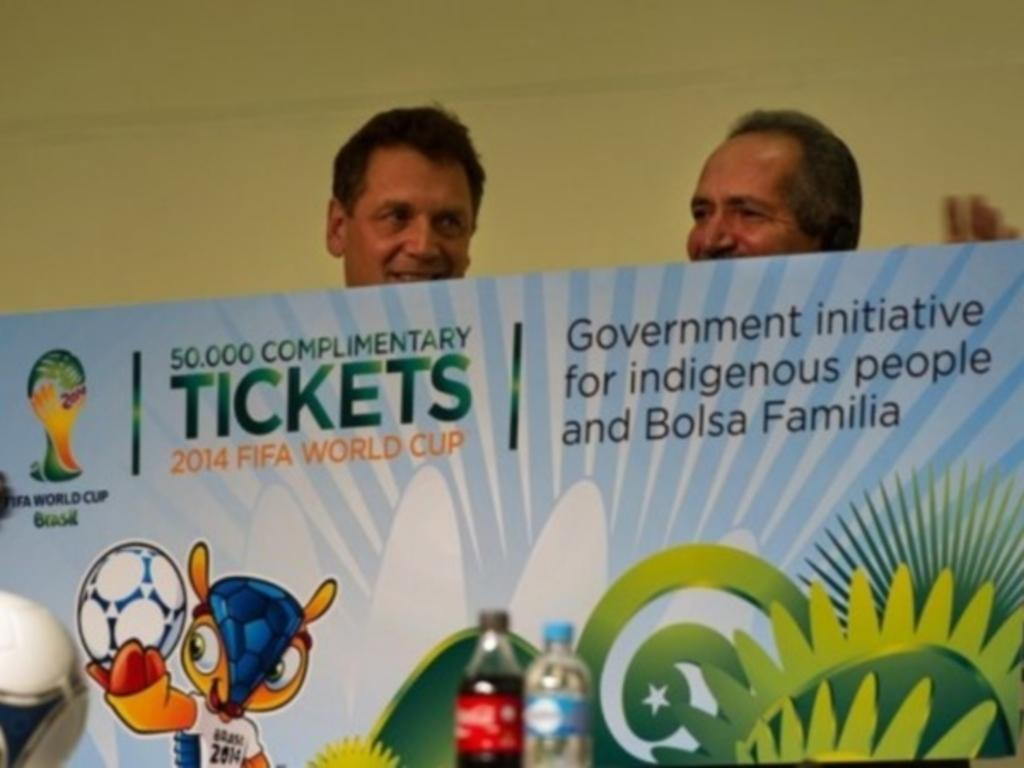What is the main object in the image? There is a board in the image. Who or what is in front of the board? Two persons are in front of the board. What else can be seen at the bottom of the image? There are bottles at the bottom of the image. Can you tell me how many worms are crawling on the board in the image? There are no worms present in the image; the board is the main object, and two persons are in front of it. 